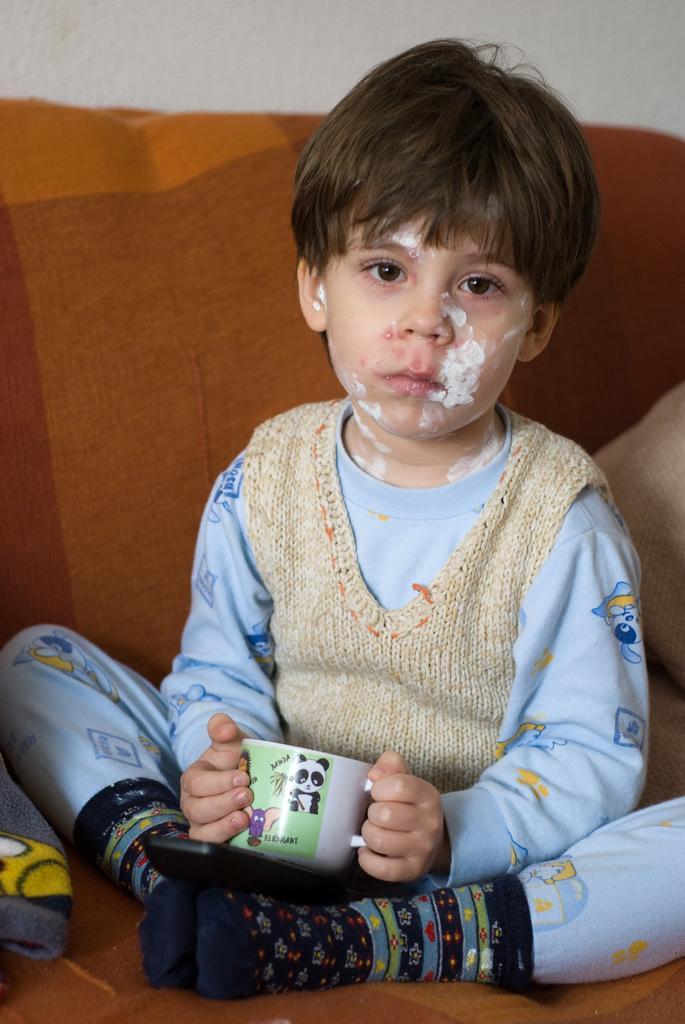In one or two sentences, can you explain what this image depicts? In the center of the image there is a kid sitting on the sofa holding a cup. In the background we can see wall. 